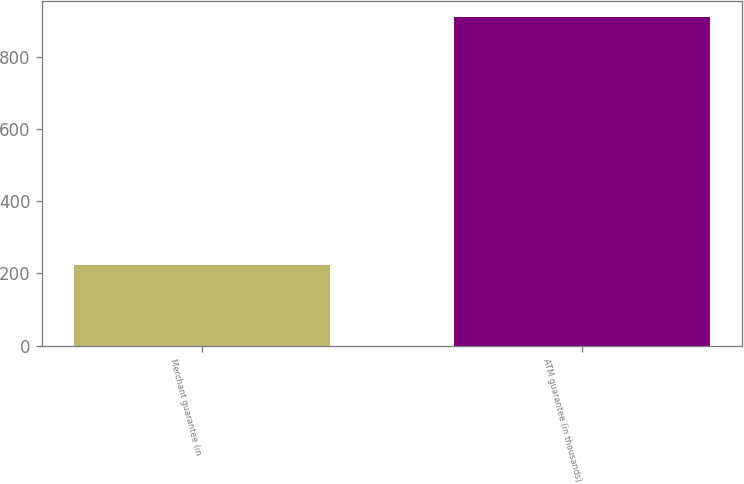Convert chart. <chart><loc_0><loc_0><loc_500><loc_500><bar_chart><fcel>Merchant guarantee (in<fcel>ATM guarantee (in thousands)<nl><fcel>224<fcel>910<nl></chart> 